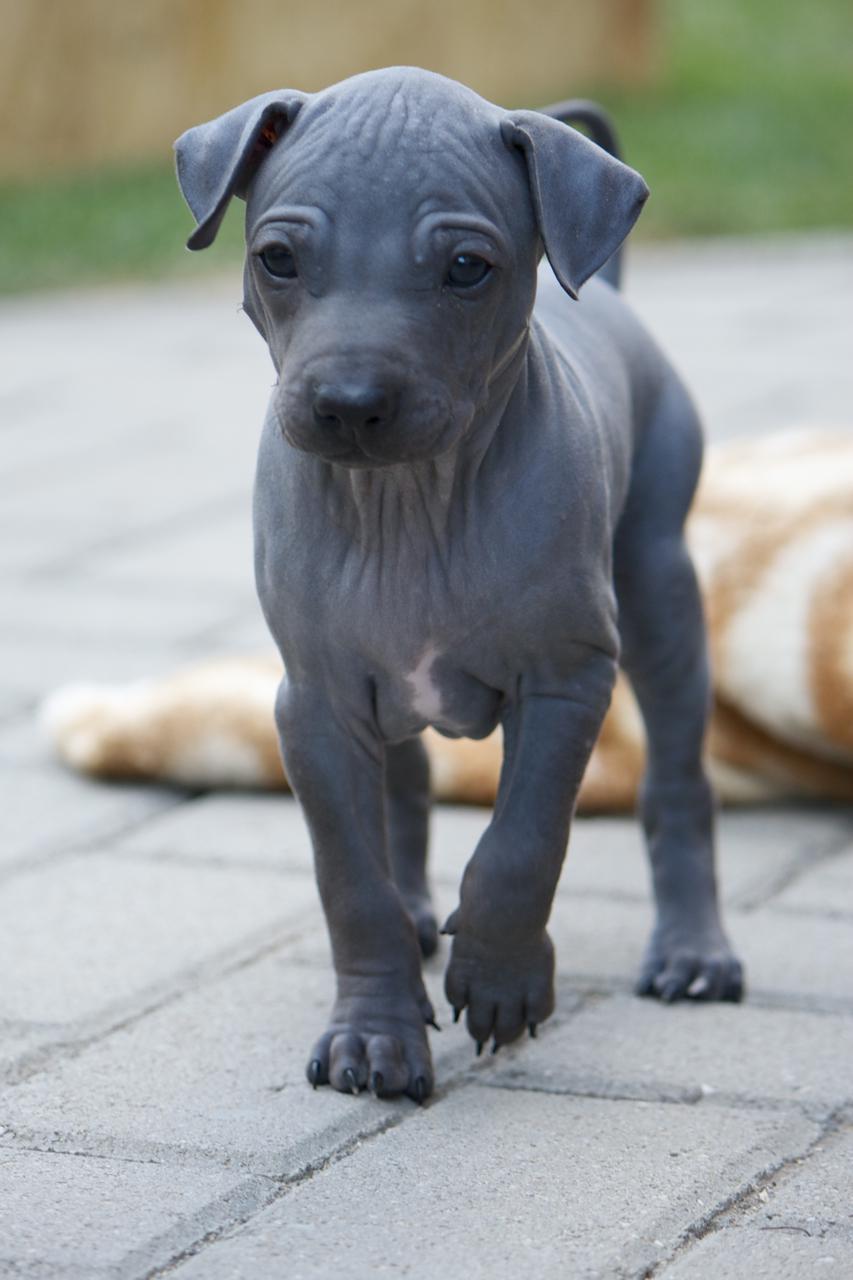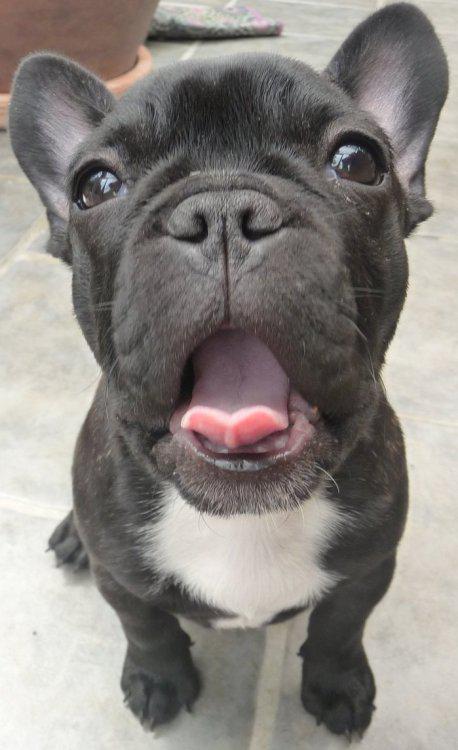The first image is the image on the left, the second image is the image on the right. Examine the images to the left and right. Is the description "A dog is standing on grass in one image and a dog is on the couch in the other." accurate? Answer yes or no. No. The first image is the image on the left, the second image is the image on the right. Considering the images on both sides, is "The dog in the right image has its mouth open and its tongue out." valid? Answer yes or no. Yes. 